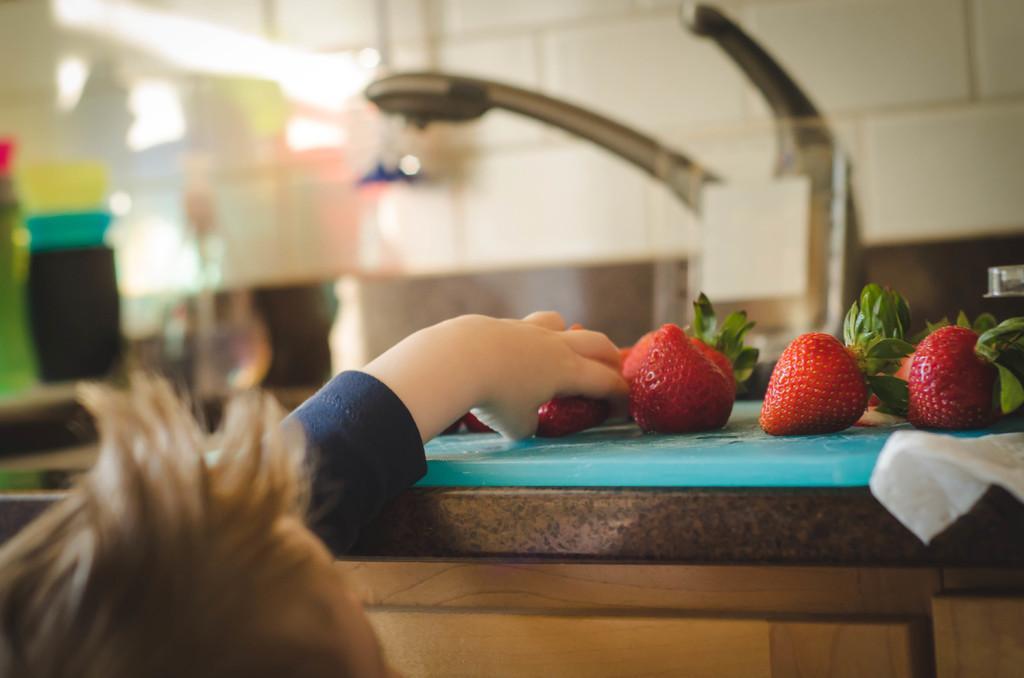Please provide a concise description of this image. In this image we can see few fruits. There is a person in the image. There are few objects in the image. There is a blur background at the top of the image. 